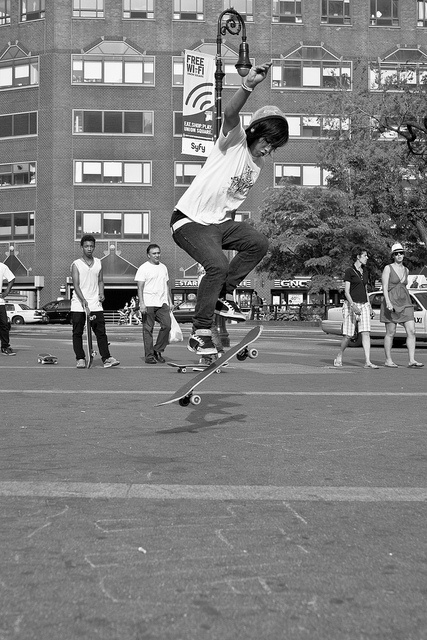Describe the objects in this image and their specific colors. I can see people in gray, black, lightgray, and darkgray tones, people in gray, black, lightgray, and darkgray tones, people in gray, white, black, and darkgray tones, people in gray, black, lightgray, and darkgray tones, and skateboard in gray, black, and lightgray tones in this image. 